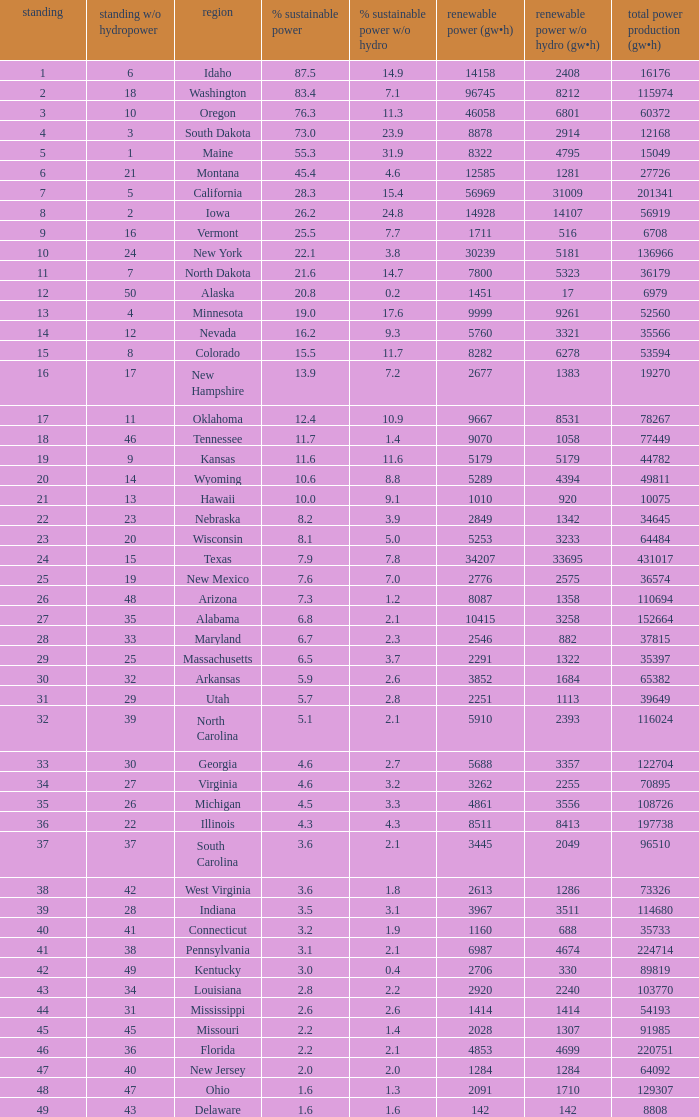Which states have renewable electricity equal to 9667 (gw×h)? Oklahoma. 